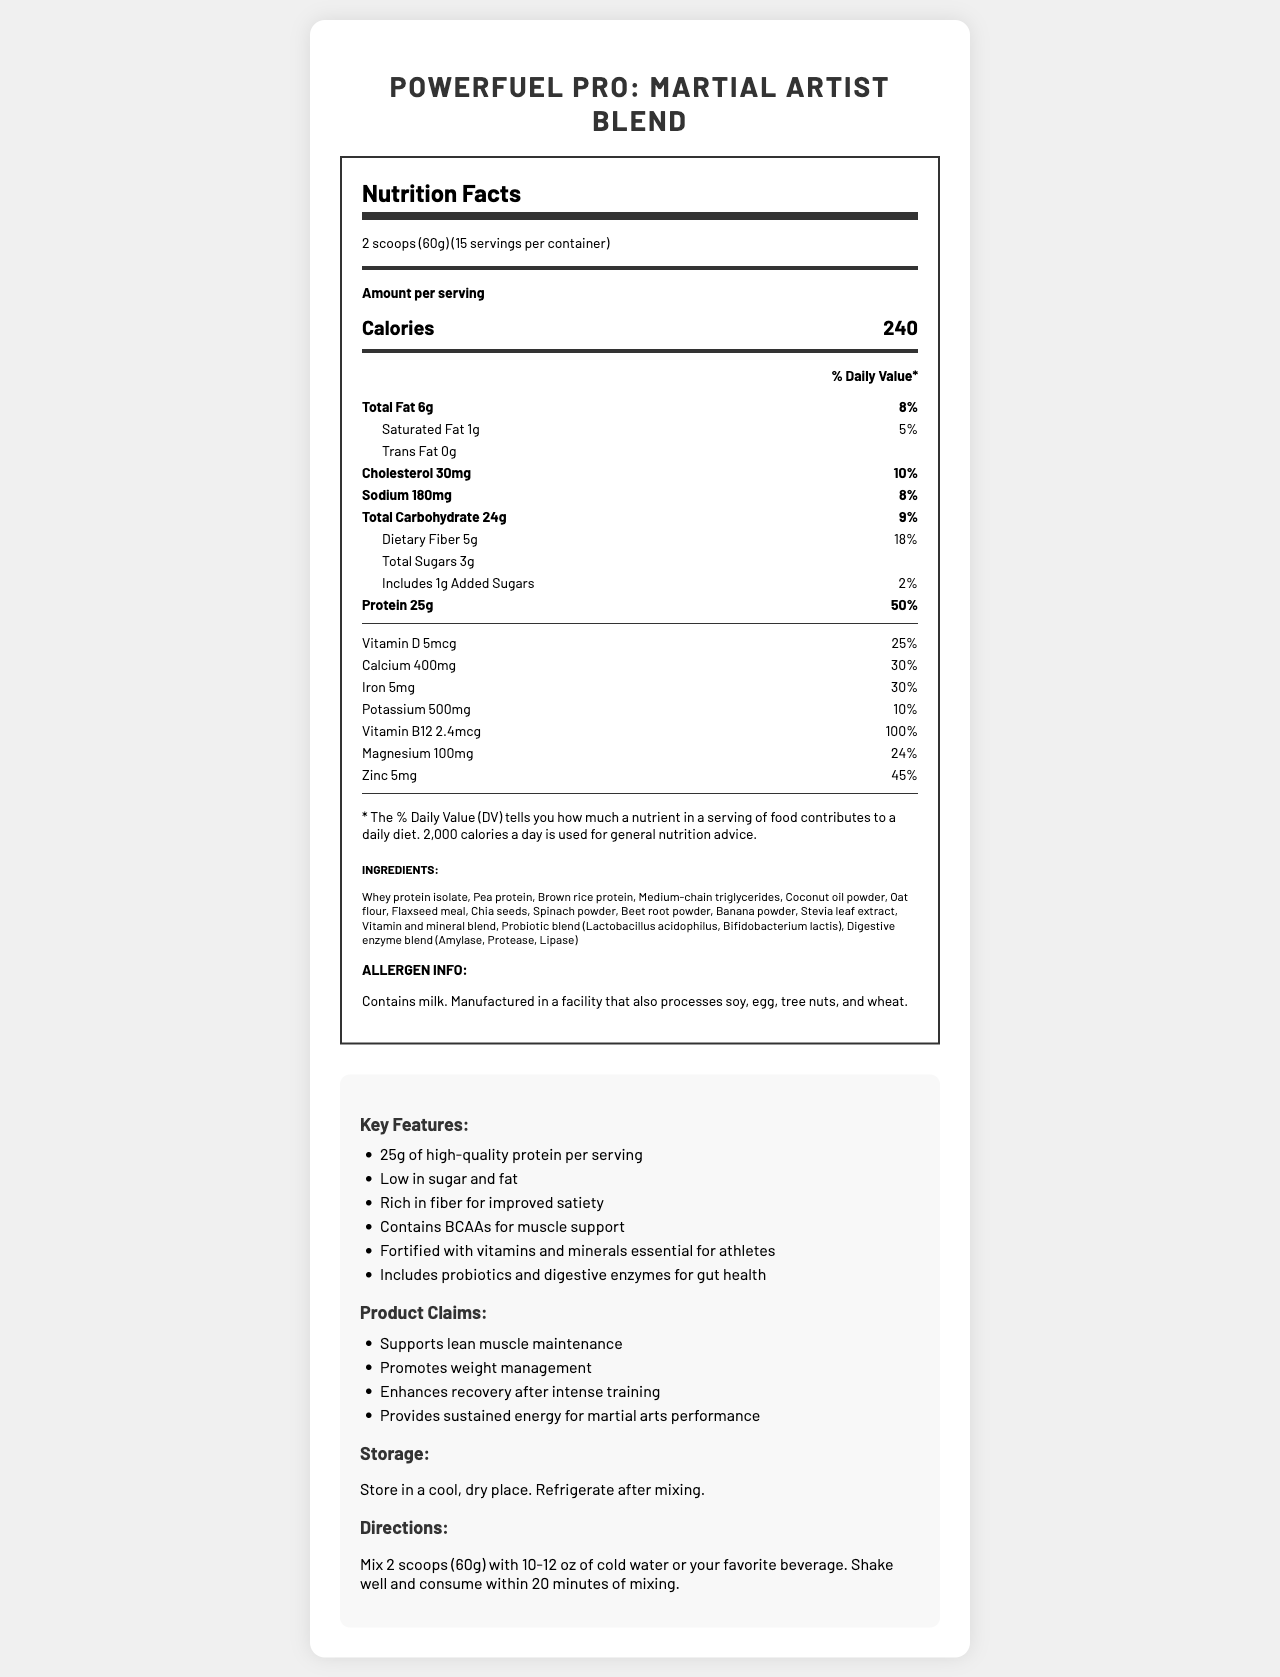What is the serving size of "PowerFuel Pro: Martial Artist Blend"? The serving size is mentioned at the beginning of the document under the product name.
Answer: 2 scoops (60g) How many servings are in one container of this meal replacement shake? The document states "15 servings per container".
Answer: 15 How many calories are in one serving of the shake? The document specifies "Calories 240" in the nutrition facts section.
Answer: 240 What percentage of daily protein does one serving provide? Under the nutrition facts, it indicates "Protein 25g" with a daily value of 50%.
Answer: 50% How much dietary fiber is in each serving and what is its daily value percentage? The nutrition facts list "Dietary Fiber 5g" with a daily value of 18%.
Answer: 5g, 18% Which vitamin has a daily value of 100% per serving? The document shows "Vitamin B12 2.4mcg" with a daily value of 100% in the nutrition section.
Answer: Vitamin B12 List two key features of the "PowerFuel Pro: Martial Artist Blend". The key features section lists these among others.
Answer: 25g of high-quality protein per serving, Low in sugar and fat What allergens are found in this meal replacement shake? The allergen info section makes this clear.
Answer: Contains milk. Manufactured in a facility that also processes soy, egg, tree nuts, and wheat. Which ingredients might contribute to muscle maintenance? These ingredients are listed first and are known for supporting muscle maintenance.
Answer: Whey protein isolate, Pea protein, Brown rice protein What is the purpose of including probiotics and digestive enzymes in the shake? A. Improve gut health B. Enhance flavor C. Increase calories D. Provide vitamins The key features mention "Includes probiotics and digestive enzymes for gut health".
Answer: A Which of the following vitamins/minerals does NOT appear in the nutrition label? A. Vitamin A B. Calcium C. Iron D. Magnesium Vitamin A is not listed in the nutrition section, whereas Calcium, Iron, and Magnesium are.
Answer: A Is there any trans fat in the "PowerFuel Pro: Martial Artist Blend"? The nutrition facts list "Trans Fat 0g".
Answer: No Does the document provide instructions on how to consume the shake? The directions section clearly states how to mix and consume the shake.
Answer: Yes Summarize the main benefits and features of "PowerFuel Pro: Martial Artist Blend". This summary covers the key points including nutritional content, main benefits, and unique features as listed in the document.
Answer: "PowerFuel Pro: Martial Artist Blend" is a nutrient-dense meal replacement shake tailored for weight management and muscle maintenance. It offers 25g of high-quality protein, 240 calories per serving, and key vitamins and minerals. It supports lean muscle, provides sustained energy, and enhances recovery for martial artists. Additionally, it includes probiotics and digestive enzymes for gut health, is low in sugar and fat, and rich in fiber for improved satiety. Is the exact composition of the probiotic blend listed? The document only mentions "Probiotic blend (Lactobacillus acidophilus, Bifidobacterium lactis)" without specifying exact amounts.
Answer: Cannot be determined 